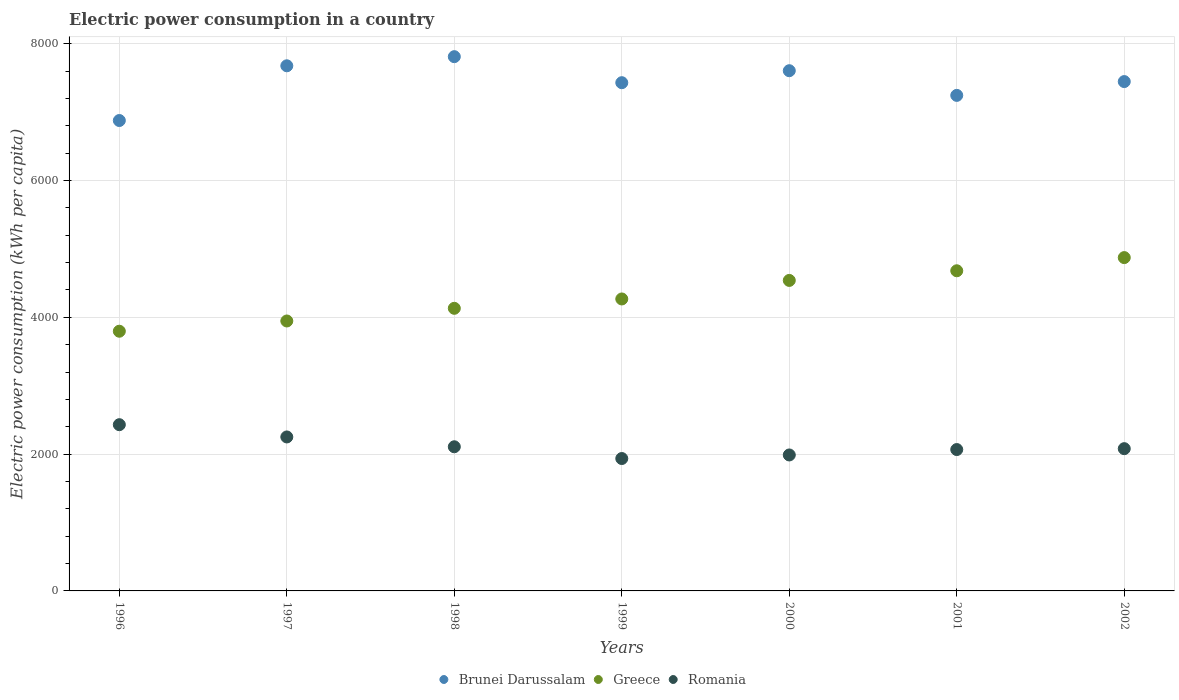How many different coloured dotlines are there?
Give a very brief answer. 3. What is the electric power consumption in in Romania in 1996?
Your answer should be very brief. 2430.3. Across all years, what is the maximum electric power consumption in in Greece?
Make the answer very short. 4873.12. Across all years, what is the minimum electric power consumption in in Greece?
Your answer should be very brief. 3796.75. What is the total electric power consumption in in Brunei Darussalam in the graph?
Make the answer very short. 5.21e+04. What is the difference between the electric power consumption in in Greece in 1996 and that in 1997?
Offer a terse response. -149.71. What is the difference between the electric power consumption in in Brunei Darussalam in 1999 and the electric power consumption in in Romania in 2001?
Ensure brevity in your answer.  5363.45. What is the average electric power consumption in in Brunei Darussalam per year?
Keep it short and to the point. 7441.71. In the year 2002, what is the difference between the electric power consumption in in Greece and electric power consumption in in Brunei Darussalam?
Offer a terse response. -2573.38. In how many years, is the electric power consumption in in Brunei Darussalam greater than 6000 kWh per capita?
Keep it short and to the point. 7. What is the ratio of the electric power consumption in in Brunei Darussalam in 2001 to that in 2002?
Offer a terse response. 0.97. Is the electric power consumption in in Greece in 1998 less than that in 2000?
Your answer should be compact. Yes. Is the difference between the electric power consumption in in Greece in 2001 and 2002 greater than the difference between the electric power consumption in in Brunei Darussalam in 2001 and 2002?
Offer a terse response. Yes. What is the difference between the highest and the second highest electric power consumption in in Brunei Darussalam?
Provide a succinct answer. 133.44. What is the difference between the highest and the lowest electric power consumption in in Romania?
Ensure brevity in your answer.  494.74. In how many years, is the electric power consumption in in Greece greater than the average electric power consumption in in Greece taken over all years?
Provide a short and direct response. 3. Does the electric power consumption in in Greece monotonically increase over the years?
Give a very brief answer. Yes. Is the electric power consumption in in Romania strictly greater than the electric power consumption in in Greece over the years?
Ensure brevity in your answer.  No. How many years are there in the graph?
Your answer should be very brief. 7. What is the difference between two consecutive major ticks on the Y-axis?
Your answer should be compact. 2000. Are the values on the major ticks of Y-axis written in scientific E-notation?
Give a very brief answer. No. Does the graph contain grids?
Your answer should be compact. Yes. How many legend labels are there?
Your answer should be very brief. 3. What is the title of the graph?
Make the answer very short. Electric power consumption in a country. What is the label or title of the X-axis?
Your response must be concise. Years. What is the label or title of the Y-axis?
Give a very brief answer. Electric power consumption (kWh per capita). What is the Electric power consumption (kWh per capita) of Brunei Darussalam in 1996?
Give a very brief answer. 6877.19. What is the Electric power consumption (kWh per capita) of Greece in 1996?
Offer a terse response. 3796.75. What is the Electric power consumption (kWh per capita) in Romania in 1996?
Provide a short and direct response. 2430.3. What is the Electric power consumption (kWh per capita) in Brunei Darussalam in 1997?
Provide a succinct answer. 7677.26. What is the Electric power consumption (kWh per capita) of Greece in 1997?
Ensure brevity in your answer.  3946.46. What is the Electric power consumption (kWh per capita) in Romania in 1997?
Give a very brief answer. 2251. What is the Electric power consumption (kWh per capita) of Brunei Darussalam in 1998?
Your response must be concise. 7810.7. What is the Electric power consumption (kWh per capita) of Greece in 1998?
Offer a terse response. 4131.66. What is the Electric power consumption (kWh per capita) in Romania in 1998?
Provide a short and direct response. 2107.45. What is the Electric power consumption (kWh per capita) in Brunei Darussalam in 1999?
Make the answer very short. 7430.24. What is the Electric power consumption (kWh per capita) in Greece in 1999?
Offer a very short reply. 4268.38. What is the Electric power consumption (kWh per capita) of Romania in 1999?
Make the answer very short. 1935.56. What is the Electric power consumption (kWh per capita) of Brunei Darussalam in 2000?
Your response must be concise. 7605.41. What is the Electric power consumption (kWh per capita) of Greece in 2000?
Provide a succinct answer. 4539.42. What is the Electric power consumption (kWh per capita) of Romania in 2000?
Provide a succinct answer. 1987.66. What is the Electric power consumption (kWh per capita) in Brunei Darussalam in 2001?
Your answer should be compact. 7244.7. What is the Electric power consumption (kWh per capita) in Greece in 2001?
Your answer should be compact. 4680.52. What is the Electric power consumption (kWh per capita) in Romania in 2001?
Your answer should be compact. 2066.78. What is the Electric power consumption (kWh per capita) in Brunei Darussalam in 2002?
Make the answer very short. 7446.5. What is the Electric power consumption (kWh per capita) of Greece in 2002?
Provide a short and direct response. 4873.12. What is the Electric power consumption (kWh per capita) in Romania in 2002?
Give a very brief answer. 2079.8. Across all years, what is the maximum Electric power consumption (kWh per capita) of Brunei Darussalam?
Provide a succinct answer. 7810.7. Across all years, what is the maximum Electric power consumption (kWh per capita) in Greece?
Offer a very short reply. 4873.12. Across all years, what is the maximum Electric power consumption (kWh per capita) of Romania?
Your answer should be compact. 2430.3. Across all years, what is the minimum Electric power consumption (kWh per capita) of Brunei Darussalam?
Keep it short and to the point. 6877.19. Across all years, what is the minimum Electric power consumption (kWh per capita) of Greece?
Provide a short and direct response. 3796.75. Across all years, what is the minimum Electric power consumption (kWh per capita) in Romania?
Offer a terse response. 1935.56. What is the total Electric power consumption (kWh per capita) in Brunei Darussalam in the graph?
Your answer should be compact. 5.21e+04. What is the total Electric power consumption (kWh per capita) in Greece in the graph?
Offer a terse response. 3.02e+04. What is the total Electric power consumption (kWh per capita) in Romania in the graph?
Provide a succinct answer. 1.49e+04. What is the difference between the Electric power consumption (kWh per capita) in Brunei Darussalam in 1996 and that in 1997?
Your response must be concise. -800.07. What is the difference between the Electric power consumption (kWh per capita) of Greece in 1996 and that in 1997?
Your answer should be compact. -149.71. What is the difference between the Electric power consumption (kWh per capita) of Romania in 1996 and that in 1997?
Keep it short and to the point. 179.3. What is the difference between the Electric power consumption (kWh per capita) of Brunei Darussalam in 1996 and that in 1998?
Provide a succinct answer. -933.51. What is the difference between the Electric power consumption (kWh per capita) of Greece in 1996 and that in 1998?
Your answer should be very brief. -334.91. What is the difference between the Electric power consumption (kWh per capita) in Romania in 1996 and that in 1998?
Your answer should be very brief. 322.86. What is the difference between the Electric power consumption (kWh per capita) in Brunei Darussalam in 1996 and that in 1999?
Provide a short and direct response. -553.04. What is the difference between the Electric power consumption (kWh per capita) of Greece in 1996 and that in 1999?
Provide a short and direct response. -471.64. What is the difference between the Electric power consumption (kWh per capita) in Romania in 1996 and that in 1999?
Make the answer very short. 494.74. What is the difference between the Electric power consumption (kWh per capita) of Brunei Darussalam in 1996 and that in 2000?
Your response must be concise. -728.22. What is the difference between the Electric power consumption (kWh per capita) in Greece in 1996 and that in 2000?
Provide a succinct answer. -742.67. What is the difference between the Electric power consumption (kWh per capita) of Romania in 1996 and that in 2000?
Provide a short and direct response. 442.64. What is the difference between the Electric power consumption (kWh per capita) in Brunei Darussalam in 1996 and that in 2001?
Give a very brief answer. -367.51. What is the difference between the Electric power consumption (kWh per capita) of Greece in 1996 and that in 2001?
Make the answer very short. -883.78. What is the difference between the Electric power consumption (kWh per capita) in Romania in 1996 and that in 2001?
Offer a terse response. 363.52. What is the difference between the Electric power consumption (kWh per capita) in Brunei Darussalam in 1996 and that in 2002?
Give a very brief answer. -569.3. What is the difference between the Electric power consumption (kWh per capita) of Greece in 1996 and that in 2002?
Your answer should be very brief. -1076.37. What is the difference between the Electric power consumption (kWh per capita) of Romania in 1996 and that in 2002?
Offer a very short reply. 350.51. What is the difference between the Electric power consumption (kWh per capita) of Brunei Darussalam in 1997 and that in 1998?
Make the answer very short. -133.44. What is the difference between the Electric power consumption (kWh per capita) in Greece in 1997 and that in 1998?
Your answer should be compact. -185.2. What is the difference between the Electric power consumption (kWh per capita) of Romania in 1997 and that in 1998?
Your answer should be compact. 143.55. What is the difference between the Electric power consumption (kWh per capita) of Brunei Darussalam in 1997 and that in 1999?
Give a very brief answer. 247.02. What is the difference between the Electric power consumption (kWh per capita) of Greece in 1997 and that in 1999?
Give a very brief answer. -321.93. What is the difference between the Electric power consumption (kWh per capita) of Romania in 1997 and that in 1999?
Your answer should be very brief. 315.44. What is the difference between the Electric power consumption (kWh per capita) in Brunei Darussalam in 1997 and that in 2000?
Provide a short and direct response. 71.84. What is the difference between the Electric power consumption (kWh per capita) in Greece in 1997 and that in 2000?
Give a very brief answer. -592.96. What is the difference between the Electric power consumption (kWh per capita) in Romania in 1997 and that in 2000?
Give a very brief answer. 263.34. What is the difference between the Electric power consumption (kWh per capita) in Brunei Darussalam in 1997 and that in 2001?
Your answer should be compact. 432.56. What is the difference between the Electric power consumption (kWh per capita) of Greece in 1997 and that in 2001?
Keep it short and to the point. -734.07. What is the difference between the Electric power consumption (kWh per capita) of Romania in 1997 and that in 2001?
Provide a short and direct response. 184.22. What is the difference between the Electric power consumption (kWh per capita) in Brunei Darussalam in 1997 and that in 2002?
Your response must be concise. 230.76. What is the difference between the Electric power consumption (kWh per capita) in Greece in 1997 and that in 2002?
Offer a very short reply. -926.66. What is the difference between the Electric power consumption (kWh per capita) of Romania in 1997 and that in 2002?
Make the answer very short. 171.2. What is the difference between the Electric power consumption (kWh per capita) of Brunei Darussalam in 1998 and that in 1999?
Offer a terse response. 380.46. What is the difference between the Electric power consumption (kWh per capita) of Greece in 1998 and that in 1999?
Make the answer very short. -136.72. What is the difference between the Electric power consumption (kWh per capita) of Romania in 1998 and that in 1999?
Provide a succinct answer. 171.88. What is the difference between the Electric power consumption (kWh per capita) of Brunei Darussalam in 1998 and that in 2000?
Your response must be concise. 205.29. What is the difference between the Electric power consumption (kWh per capita) in Greece in 1998 and that in 2000?
Provide a short and direct response. -407.76. What is the difference between the Electric power consumption (kWh per capita) of Romania in 1998 and that in 2000?
Your answer should be very brief. 119.79. What is the difference between the Electric power consumption (kWh per capita) of Brunei Darussalam in 1998 and that in 2001?
Ensure brevity in your answer.  566. What is the difference between the Electric power consumption (kWh per capita) in Greece in 1998 and that in 2001?
Provide a succinct answer. -548.87. What is the difference between the Electric power consumption (kWh per capita) in Romania in 1998 and that in 2001?
Your answer should be compact. 40.66. What is the difference between the Electric power consumption (kWh per capita) of Brunei Darussalam in 1998 and that in 2002?
Your answer should be very brief. 364.2. What is the difference between the Electric power consumption (kWh per capita) of Greece in 1998 and that in 2002?
Offer a terse response. -741.46. What is the difference between the Electric power consumption (kWh per capita) of Romania in 1998 and that in 2002?
Make the answer very short. 27.65. What is the difference between the Electric power consumption (kWh per capita) in Brunei Darussalam in 1999 and that in 2000?
Give a very brief answer. -175.18. What is the difference between the Electric power consumption (kWh per capita) in Greece in 1999 and that in 2000?
Provide a short and direct response. -271.04. What is the difference between the Electric power consumption (kWh per capita) of Romania in 1999 and that in 2000?
Keep it short and to the point. -52.1. What is the difference between the Electric power consumption (kWh per capita) in Brunei Darussalam in 1999 and that in 2001?
Offer a terse response. 185.54. What is the difference between the Electric power consumption (kWh per capita) in Greece in 1999 and that in 2001?
Provide a succinct answer. -412.14. What is the difference between the Electric power consumption (kWh per capita) of Romania in 1999 and that in 2001?
Provide a succinct answer. -131.22. What is the difference between the Electric power consumption (kWh per capita) in Brunei Darussalam in 1999 and that in 2002?
Provide a succinct answer. -16.26. What is the difference between the Electric power consumption (kWh per capita) of Greece in 1999 and that in 2002?
Offer a terse response. -604.74. What is the difference between the Electric power consumption (kWh per capita) in Romania in 1999 and that in 2002?
Provide a short and direct response. -144.24. What is the difference between the Electric power consumption (kWh per capita) of Brunei Darussalam in 2000 and that in 2001?
Your response must be concise. 360.71. What is the difference between the Electric power consumption (kWh per capita) in Greece in 2000 and that in 2001?
Make the answer very short. -141.11. What is the difference between the Electric power consumption (kWh per capita) of Romania in 2000 and that in 2001?
Make the answer very short. -79.12. What is the difference between the Electric power consumption (kWh per capita) of Brunei Darussalam in 2000 and that in 2002?
Make the answer very short. 158.92. What is the difference between the Electric power consumption (kWh per capita) of Greece in 2000 and that in 2002?
Provide a short and direct response. -333.7. What is the difference between the Electric power consumption (kWh per capita) of Romania in 2000 and that in 2002?
Give a very brief answer. -92.14. What is the difference between the Electric power consumption (kWh per capita) of Brunei Darussalam in 2001 and that in 2002?
Make the answer very short. -201.8. What is the difference between the Electric power consumption (kWh per capita) in Greece in 2001 and that in 2002?
Make the answer very short. -192.6. What is the difference between the Electric power consumption (kWh per capita) of Romania in 2001 and that in 2002?
Your answer should be compact. -13.01. What is the difference between the Electric power consumption (kWh per capita) of Brunei Darussalam in 1996 and the Electric power consumption (kWh per capita) of Greece in 1997?
Offer a very short reply. 2930.74. What is the difference between the Electric power consumption (kWh per capita) of Brunei Darussalam in 1996 and the Electric power consumption (kWh per capita) of Romania in 1997?
Your response must be concise. 4626.19. What is the difference between the Electric power consumption (kWh per capita) of Greece in 1996 and the Electric power consumption (kWh per capita) of Romania in 1997?
Ensure brevity in your answer.  1545.75. What is the difference between the Electric power consumption (kWh per capita) of Brunei Darussalam in 1996 and the Electric power consumption (kWh per capita) of Greece in 1998?
Offer a terse response. 2745.54. What is the difference between the Electric power consumption (kWh per capita) in Brunei Darussalam in 1996 and the Electric power consumption (kWh per capita) in Romania in 1998?
Keep it short and to the point. 4769.75. What is the difference between the Electric power consumption (kWh per capita) of Greece in 1996 and the Electric power consumption (kWh per capita) of Romania in 1998?
Provide a short and direct response. 1689.3. What is the difference between the Electric power consumption (kWh per capita) in Brunei Darussalam in 1996 and the Electric power consumption (kWh per capita) in Greece in 1999?
Offer a terse response. 2608.81. What is the difference between the Electric power consumption (kWh per capita) of Brunei Darussalam in 1996 and the Electric power consumption (kWh per capita) of Romania in 1999?
Provide a succinct answer. 4941.63. What is the difference between the Electric power consumption (kWh per capita) of Greece in 1996 and the Electric power consumption (kWh per capita) of Romania in 1999?
Your answer should be compact. 1861.18. What is the difference between the Electric power consumption (kWh per capita) in Brunei Darussalam in 1996 and the Electric power consumption (kWh per capita) in Greece in 2000?
Offer a very short reply. 2337.78. What is the difference between the Electric power consumption (kWh per capita) of Brunei Darussalam in 1996 and the Electric power consumption (kWh per capita) of Romania in 2000?
Your answer should be very brief. 4889.53. What is the difference between the Electric power consumption (kWh per capita) in Greece in 1996 and the Electric power consumption (kWh per capita) in Romania in 2000?
Offer a very short reply. 1809.08. What is the difference between the Electric power consumption (kWh per capita) in Brunei Darussalam in 1996 and the Electric power consumption (kWh per capita) in Greece in 2001?
Offer a terse response. 2196.67. What is the difference between the Electric power consumption (kWh per capita) of Brunei Darussalam in 1996 and the Electric power consumption (kWh per capita) of Romania in 2001?
Offer a terse response. 4810.41. What is the difference between the Electric power consumption (kWh per capita) in Greece in 1996 and the Electric power consumption (kWh per capita) in Romania in 2001?
Give a very brief answer. 1729.96. What is the difference between the Electric power consumption (kWh per capita) in Brunei Darussalam in 1996 and the Electric power consumption (kWh per capita) in Greece in 2002?
Keep it short and to the point. 2004.07. What is the difference between the Electric power consumption (kWh per capita) in Brunei Darussalam in 1996 and the Electric power consumption (kWh per capita) in Romania in 2002?
Provide a succinct answer. 4797.4. What is the difference between the Electric power consumption (kWh per capita) in Greece in 1996 and the Electric power consumption (kWh per capita) in Romania in 2002?
Give a very brief answer. 1716.95. What is the difference between the Electric power consumption (kWh per capita) of Brunei Darussalam in 1997 and the Electric power consumption (kWh per capita) of Greece in 1998?
Offer a terse response. 3545.6. What is the difference between the Electric power consumption (kWh per capita) in Brunei Darussalam in 1997 and the Electric power consumption (kWh per capita) in Romania in 1998?
Your answer should be very brief. 5569.81. What is the difference between the Electric power consumption (kWh per capita) in Greece in 1997 and the Electric power consumption (kWh per capita) in Romania in 1998?
Offer a very short reply. 1839.01. What is the difference between the Electric power consumption (kWh per capita) of Brunei Darussalam in 1997 and the Electric power consumption (kWh per capita) of Greece in 1999?
Your answer should be very brief. 3408.88. What is the difference between the Electric power consumption (kWh per capita) in Brunei Darussalam in 1997 and the Electric power consumption (kWh per capita) in Romania in 1999?
Provide a succinct answer. 5741.7. What is the difference between the Electric power consumption (kWh per capita) of Greece in 1997 and the Electric power consumption (kWh per capita) of Romania in 1999?
Give a very brief answer. 2010.9. What is the difference between the Electric power consumption (kWh per capita) in Brunei Darussalam in 1997 and the Electric power consumption (kWh per capita) in Greece in 2000?
Offer a terse response. 3137.84. What is the difference between the Electric power consumption (kWh per capita) of Brunei Darussalam in 1997 and the Electric power consumption (kWh per capita) of Romania in 2000?
Offer a terse response. 5689.6. What is the difference between the Electric power consumption (kWh per capita) in Greece in 1997 and the Electric power consumption (kWh per capita) in Romania in 2000?
Your answer should be very brief. 1958.8. What is the difference between the Electric power consumption (kWh per capita) in Brunei Darussalam in 1997 and the Electric power consumption (kWh per capita) in Greece in 2001?
Keep it short and to the point. 2996.73. What is the difference between the Electric power consumption (kWh per capita) in Brunei Darussalam in 1997 and the Electric power consumption (kWh per capita) in Romania in 2001?
Your response must be concise. 5610.47. What is the difference between the Electric power consumption (kWh per capita) of Greece in 1997 and the Electric power consumption (kWh per capita) of Romania in 2001?
Your answer should be very brief. 1879.67. What is the difference between the Electric power consumption (kWh per capita) of Brunei Darussalam in 1997 and the Electric power consumption (kWh per capita) of Greece in 2002?
Your answer should be compact. 2804.14. What is the difference between the Electric power consumption (kWh per capita) of Brunei Darussalam in 1997 and the Electric power consumption (kWh per capita) of Romania in 2002?
Your answer should be compact. 5597.46. What is the difference between the Electric power consumption (kWh per capita) in Greece in 1997 and the Electric power consumption (kWh per capita) in Romania in 2002?
Keep it short and to the point. 1866.66. What is the difference between the Electric power consumption (kWh per capita) of Brunei Darussalam in 1998 and the Electric power consumption (kWh per capita) of Greece in 1999?
Offer a terse response. 3542.32. What is the difference between the Electric power consumption (kWh per capita) of Brunei Darussalam in 1998 and the Electric power consumption (kWh per capita) of Romania in 1999?
Give a very brief answer. 5875.14. What is the difference between the Electric power consumption (kWh per capita) of Greece in 1998 and the Electric power consumption (kWh per capita) of Romania in 1999?
Your answer should be compact. 2196.1. What is the difference between the Electric power consumption (kWh per capita) of Brunei Darussalam in 1998 and the Electric power consumption (kWh per capita) of Greece in 2000?
Offer a terse response. 3271.28. What is the difference between the Electric power consumption (kWh per capita) of Brunei Darussalam in 1998 and the Electric power consumption (kWh per capita) of Romania in 2000?
Keep it short and to the point. 5823.04. What is the difference between the Electric power consumption (kWh per capita) of Greece in 1998 and the Electric power consumption (kWh per capita) of Romania in 2000?
Your answer should be very brief. 2144. What is the difference between the Electric power consumption (kWh per capita) of Brunei Darussalam in 1998 and the Electric power consumption (kWh per capita) of Greece in 2001?
Offer a very short reply. 3130.18. What is the difference between the Electric power consumption (kWh per capita) of Brunei Darussalam in 1998 and the Electric power consumption (kWh per capita) of Romania in 2001?
Offer a terse response. 5743.92. What is the difference between the Electric power consumption (kWh per capita) in Greece in 1998 and the Electric power consumption (kWh per capita) in Romania in 2001?
Your response must be concise. 2064.87. What is the difference between the Electric power consumption (kWh per capita) in Brunei Darussalam in 1998 and the Electric power consumption (kWh per capita) in Greece in 2002?
Offer a terse response. 2937.58. What is the difference between the Electric power consumption (kWh per capita) in Brunei Darussalam in 1998 and the Electric power consumption (kWh per capita) in Romania in 2002?
Ensure brevity in your answer.  5730.9. What is the difference between the Electric power consumption (kWh per capita) in Greece in 1998 and the Electric power consumption (kWh per capita) in Romania in 2002?
Your response must be concise. 2051.86. What is the difference between the Electric power consumption (kWh per capita) in Brunei Darussalam in 1999 and the Electric power consumption (kWh per capita) in Greece in 2000?
Your response must be concise. 2890.82. What is the difference between the Electric power consumption (kWh per capita) in Brunei Darussalam in 1999 and the Electric power consumption (kWh per capita) in Romania in 2000?
Your answer should be very brief. 5442.58. What is the difference between the Electric power consumption (kWh per capita) in Greece in 1999 and the Electric power consumption (kWh per capita) in Romania in 2000?
Your response must be concise. 2280.72. What is the difference between the Electric power consumption (kWh per capita) in Brunei Darussalam in 1999 and the Electric power consumption (kWh per capita) in Greece in 2001?
Give a very brief answer. 2749.71. What is the difference between the Electric power consumption (kWh per capita) of Brunei Darussalam in 1999 and the Electric power consumption (kWh per capita) of Romania in 2001?
Keep it short and to the point. 5363.45. What is the difference between the Electric power consumption (kWh per capita) in Greece in 1999 and the Electric power consumption (kWh per capita) in Romania in 2001?
Your answer should be very brief. 2201.6. What is the difference between the Electric power consumption (kWh per capita) of Brunei Darussalam in 1999 and the Electric power consumption (kWh per capita) of Greece in 2002?
Provide a succinct answer. 2557.12. What is the difference between the Electric power consumption (kWh per capita) in Brunei Darussalam in 1999 and the Electric power consumption (kWh per capita) in Romania in 2002?
Your answer should be very brief. 5350.44. What is the difference between the Electric power consumption (kWh per capita) of Greece in 1999 and the Electric power consumption (kWh per capita) of Romania in 2002?
Keep it short and to the point. 2188.59. What is the difference between the Electric power consumption (kWh per capita) in Brunei Darussalam in 2000 and the Electric power consumption (kWh per capita) in Greece in 2001?
Your answer should be compact. 2924.89. What is the difference between the Electric power consumption (kWh per capita) of Brunei Darussalam in 2000 and the Electric power consumption (kWh per capita) of Romania in 2001?
Make the answer very short. 5538.63. What is the difference between the Electric power consumption (kWh per capita) in Greece in 2000 and the Electric power consumption (kWh per capita) in Romania in 2001?
Keep it short and to the point. 2472.63. What is the difference between the Electric power consumption (kWh per capita) of Brunei Darussalam in 2000 and the Electric power consumption (kWh per capita) of Greece in 2002?
Provide a short and direct response. 2732.29. What is the difference between the Electric power consumption (kWh per capita) of Brunei Darussalam in 2000 and the Electric power consumption (kWh per capita) of Romania in 2002?
Provide a short and direct response. 5525.62. What is the difference between the Electric power consumption (kWh per capita) of Greece in 2000 and the Electric power consumption (kWh per capita) of Romania in 2002?
Keep it short and to the point. 2459.62. What is the difference between the Electric power consumption (kWh per capita) of Brunei Darussalam in 2001 and the Electric power consumption (kWh per capita) of Greece in 2002?
Ensure brevity in your answer.  2371.58. What is the difference between the Electric power consumption (kWh per capita) in Brunei Darussalam in 2001 and the Electric power consumption (kWh per capita) in Romania in 2002?
Make the answer very short. 5164.9. What is the difference between the Electric power consumption (kWh per capita) of Greece in 2001 and the Electric power consumption (kWh per capita) of Romania in 2002?
Make the answer very short. 2600.73. What is the average Electric power consumption (kWh per capita) of Brunei Darussalam per year?
Give a very brief answer. 7441.71. What is the average Electric power consumption (kWh per capita) of Greece per year?
Your answer should be compact. 4319.47. What is the average Electric power consumption (kWh per capita) in Romania per year?
Ensure brevity in your answer.  2122.65. In the year 1996, what is the difference between the Electric power consumption (kWh per capita) in Brunei Darussalam and Electric power consumption (kWh per capita) in Greece?
Give a very brief answer. 3080.45. In the year 1996, what is the difference between the Electric power consumption (kWh per capita) of Brunei Darussalam and Electric power consumption (kWh per capita) of Romania?
Ensure brevity in your answer.  4446.89. In the year 1996, what is the difference between the Electric power consumption (kWh per capita) of Greece and Electric power consumption (kWh per capita) of Romania?
Offer a terse response. 1366.44. In the year 1997, what is the difference between the Electric power consumption (kWh per capita) in Brunei Darussalam and Electric power consumption (kWh per capita) in Greece?
Offer a terse response. 3730.8. In the year 1997, what is the difference between the Electric power consumption (kWh per capita) in Brunei Darussalam and Electric power consumption (kWh per capita) in Romania?
Your answer should be compact. 5426.26. In the year 1997, what is the difference between the Electric power consumption (kWh per capita) in Greece and Electric power consumption (kWh per capita) in Romania?
Keep it short and to the point. 1695.46. In the year 1998, what is the difference between the Electric power consumption (kWh per capita) in Brunei Darussalam and Electric power consumption (kWh per capita) in Greece?
Provide a succinct answer. 3679.04. In the year 1998, what is the difference between the Electric power consumption (kWh per capita) of Brunei Darussalam and Electric power consumption (kWh per capita) of Romania?
Your answer should be compact. 5703.25. In the year 1998, what is the difference between the Electric power consumption (kWh per capita) of Greece and Electric power consumption (kWh per capita) of Romania?
Your answer should be compact. 2024.21. In the year 1999, what is the difference between the Electric power consumption (kWh per capita) of Brunei Darussalam and Electric power consumption (kWh per capita) of Greece?
Your answer should be compact. 3161.86. In the year 1999, what is the difference between the Electric power consumption (kWh per capita) in Brunei Darussalam and Electric power consumption (kWh per capita) in Romania?
Offer a terse response. 5494.68. In the year 1999, what is the difference between the Electric power consumption (kWh per capita) of Greece and Electric power consumption (kWh per capita) of Romania?
Your answer should be very brief. 2332.82. In the year 2000, what is the difference between the Electric power consumption (kWh per capita) of Brunei Darussalam and Electric power consumption (kWh per capita) of Greece?
Your answer should be compact. 3066. In the year 2000, what is the difference between the Electric power consumption (kWh per capita) in Brunei Darussalam and Electric power consumption (kWh per capita) in Romania?
Offer a very short reply. 5617.75. In the year 2000, what is the difference between the Electric power consumption (kWh per capita) in Greece and Electric power consumption (kWh per capita) in Romania?
Make the answer very short. 2551.76. In the year 2001, what is the difference between the Electric power consumption (kWh per capita) in Brunei Darussalam and Electric power consumption (kWh per capita) in Greece?
Ensure brevity in your answer.  2564.18. In the year 2001, what is the difference between the Electric power consumption (kWh per capita) in Brunei Darussalam and Electric power consumption (kWh per capita) in Romania?
Your response must be concise. 5177.92. In the year 2001, what is the difference between the Electric power consumption (kWh per capita) of Greece and Electric power consumption (kWh per capita) of Romania?
Ensure brevity in your answer.  2613.74. In the year 2002, what is the difference between the Electric power consumption (kWh per capita) in Brunei Darussalam and Electric power consumption (kWh per capita) in Greece?
Your answer should be compact. 2573.38. In the year 2002, what is the difference between the Electric power consumption (kWh per capita) of Brunei Darussalam and Electric power consumption (kWh per capita) of Romania?
Ensure brevity in your answer.  5366.7. In the year 2002, what is the difference between the Electric power consumption (kWh per capita) of Greece and Electric power consumption (kWh per capita) of Romania?
Your response must be concise. 2793.32. What is the ratio of the Electric power consumption (kWh per capita) of Brunei Darussalam in 1996 to that in 1997?
Provide a short and direct response. 0.9. What is the ratio of the Electric power consumption (kWh per capita) in Greece in 1996 to that in 1997?
Give a very brief answer. 0.96. What is the ratio of the Electric power consumption (kWh per capita) of Romania in 1996 to that in 1997?
Your response must be concise. 1.08. What is the ratio of the Electric power consumption (kWh per capita) in Brunei Darussalam in 1996 to that in 1998?
Ensure brevity in your answer.  0.88. What is the ratio of the Electric power consumption (kWh per capita) of Greece in 1996 to that in 1998?
Provide a short and direct response. 0.92. What is the ratio of the Electric power consumption (kWh per capita) in Romania in 1996 to that in 1998?
Your answer should be compact. 1.15. What is the ratio of the Electric power consumption (kWh per capita) in Brunei Darussalam in 1996 to that in 1999?
Your response must be concise. 0.93. What is the ratio of the Electric power consumption (kWh per capita) in Greece in 1996 to that in 1999?
Ensure brevity in your answer.  0.89. What is the ratio of the Electric power consumption (kWh per capita) in Romania in 1996 to that in 1999?
Provide a succinct answer. 1.26. What is the ratio of the Electric power consumption (kWh per capita) in Brunei Darussalam in 1996 to that in 2000?
Give a very brief answer. 0.9. What is the ratio of the Electric power consumption (kWh per capita) in Greece in 1996 to that in 2000?
Your answer should be compact. 0.84. What is the ratio of the Electric power consumption (kWh per capita) in Romania in 1996 to that in 2000?
Ensure brevity in your answer.  1.22. What is the ratio of the Electric power consumption (kWh per capita) of Brunei Darussalam in 1996 to that in 2001?
Ensure brevity in your answer.  0.95. What is the ratio of the Electric power consumption (kWh per capita) in Greece in 1996 to that in 2001?
Make the answer very short. 0.81. What is the ratio of the Electric power consumption (kWh per capita) in Romania in 1996 to that in 2001?
Give a very brief answer. 1.18. What is the ratio of the Electric power consumption (kWh per capita) of Brunei Darussalam in 1996 to that in 2002?
Keep it short and to the point. 0.92. What is the ratio of the Electric power consumption (kWh per capita) in Greece in 1996 to that in 2002?
Give a very brief answer. 0.78. What is the ratio of the Electric power consumption (kWh per capita) in Romania in 1996 to that in 2002?
Give a very brief answer. 1.17. What is the ratio of the Electric power consumption (kWh per capita) of Brunei Darussalam in 1997 to that in 1998?
Your response must be concise. 0.98. What is the ratio of the Electric power consumption (kWh per capita) of Greece in 1997 to that in 1998?
Your response must be concise. 0.96. What is the ratio of the Electric power consumption (kWh per capita) in Romania in 1997 to that in 1998?
Provide a succinct answer. 1.07. What is the ratio of the Electric power consumption (kWh per capita) in Brunei Darussalam in 1997 to that in 1999?
Offer a terse response. 1.03. What is the ratio of the Electric power consumption (kWh per capita) of Greece in 1997 to that in 1999?
Provide a short and direct response. 0.92. What is the ratio of the Electric power consumption (kWh per capita) of Romania in 1997 to that in 1999?
Give a very brief answer. 1.16. What is the ratio of the Electric power consumption (kWh per capita) of Brunei Darussalam in 1997 to that in 2000?
Your answer should be very brief. 1.01. What is the ratio of the Electric power consumption (kWh per capita) in Greece in 1997 to that in 2000?
Your answer should be compact. 0.87. What is the ratio of the Electric power consumption (kWh per capita) of Romania in 1997 to that in 2000?
Provide a succinct answer. 1.13. What is the ratio of the Electric power consumption (kWh per capita) of Brunei Darussalam in 1997 to that in 2001?
Provide a succinct answer. 1.06. What is the ratio of the Electric power consumption (kWh per capita) in Greece in 1997 to that in 2001?
Offer a terse response. 0.84. What is the ratio of the Electric power consumption (kWh per capita) in Romania in 1997 to that in 2001?
Provide a succinct answer. 1.09. What is the ratio of the Electric power consumption (kWh per capita) in Brunei Darussalam in 1997 to that in 2002?
Make the answer very short. 1.03. What is the ratio of the Electric power consumption (kWh per capita) of Greece in 1997 to that in 2002?
Offer a very short reply. 0.81. What is the ratio of the Electric power consumption (kWh per capita) in Romania in 1997 to that in 2002?
Provide a short and direct response. 1.08. What is the ratio of the Electric power consumption (kWh per capita) of Brunei Darussalam in 1998 to that in 1999?
Keep it short and to the point. 1.05. What is the ratio of the Electric power consumption (kWh per capita) of Greece in 1998 to that in 1999?
Ensure brevity in your answer.  0.97. What is the ratio of the Electric power consumption (kWh per capita) in Romania in 1998 to that in 1999?
Offer a very short reply. 1.09. What is the ratio of the Electric power consumption (kWh per capita) of Greece in 1998 to that in 2000?
Your response must be concise. 0.91. What is the ratio of the Electric power consumption (kWh per capita) in Romania in 1998 to that in 2000?
Give a very brief answer. 1.06. What is the ratio of the Electric power consumption (kWh per capita) in Brunei Darussalam in 1998 to that in 2001?
Ensure brevity in your answer.  1.08. What is the ratio of the Electric power consumption (kWh per capita) in Greece in 1998 to that in 2001?
Your answer should be compact. 0.88. What is the ratio of the Electric power consumption (kWh per capita) in Romania in 1998 to that in 2001?
Provide a short and direct response. 1.02. What is the ratio of the Electric power consumption (kWh per capita) in Brunei Darussalam in 1998 to that in 2002?
Provide a short and direct response. 1.05. What is the ratio of the Electric power consumption (kWh per capita) of Greece in 1998 to that in 2002?
Ensure brevity in your answer.  0.85. What is the ratio of the Electric power consumption (kWh per capita) in Romania in 1998 to that in 2002?
Provide a short and direct response. 1.01. What is the ratio of the Electric power consumption (kWh per capita) of Brunei Darussalam in 1999 to that in 2000?
Provide a succinct answer. 0.98. What is the ratio of the Electric power consumption (kWh per capita) in Greece in 1999 to that in 2000?
Provide a short and direct response. 0.94. What is the ratio of the Electric power consumption (kWh per capita) in Romania in 1999 to that in 2000?
Provide a succinct answer. 0.97. What is the ratio of the Electric power consumption (kWh per capita) of Brunei Darussalam in 1999 to that in 2001?
Provide a short and direct response. 1.03. What is the ratio of the Electric power consumption (kWh per capita) of Greece in 1999 to that in 2001?
Give a very brief answer. 0.91. What is the ratio of the Electric power consumption (kWh per capita) of Romania in 1999 to that in 2001?
Offer a very short reply. 0.94. What is the ratio of the Electric power consumption (kWh per capita) in Brunei Darussalam in 1999 to that in 2002?
Keep it short and to the point. 1. What is the ratio of the Electric power consumption (kWh per capita) of Greece in 1999 to that in 2002?
Your answer should be compact. 0.88. What is the ratio of the Electric power consumption (kWh per capita) in Romania in 1999 to that in 2002?
Keep it short and to the point. 0.93. What is the ratio of the Electric power consumption (kWh per capita) of Brunei Darussalam in 2000 to that in 2001?
Provide a short and direct response. 1.05. What is the ratio of the Electric power consumption (kWh per capita) in Greece in 2000 to that in 2001?
Provide a succinct answer. 0.97. What is the ratio of the Electric power consumption (kWh per capita) in Romania in 2000 to that in 2001?
Give a very brief answer. 0.96. What is the ratio of the Electric power consumption (kWh per capita) of Brunei Darussalam in 2000 to that in 2002?
Your answer should be compact. 1.02. What is the ratio of the Electric power consumption (kWh per capita) in Greece in 2000 to that in 2002?
Offer a very short reply. 0.93. What is the ratio of the Electric power consumption (kWh per capita) in Romania in 2000 to that in 2002?
Provide a succinct answer. 0.96. What is the ratio of the Electric power consumption (kWh per capita) of Brunei Darussalam in 2001 to that in 2002?
Provide a short and direct response. 0.97. What is the ratio of the Electric power consumption (kWh per capita) of Greece in 2001 to that in 2002?
Keep it short and to the point. 0.96. What is the difference between the highest and the second highest Electric power consumption (kWh per capita) of Brunei Darussalam?
Provide a short and direct response. 133.44. What is the difference between the highest and the second highest Electric power consumption (kWh per capita) in Greece?
Offer a very short reply. 192.6. What is the difference between the highest and the second highest Electric power consumption (kWh per capita) in Romania?
Offer a very short reply. 179.3. What is the difference between the highest and the lowest Electric power consumption (kWh per capita) in Brunei Darussalam?
Offer a very short reply. 933.51. What is the difference between the highest and the lowest Electric power consumption (kWh per capita) in Greece?
Ensure brevity in your answer.  1076.37. What is the difference between the highest and the lowest Electric power consumption (kWh per capita) in Romania?
Your answer should be very brief. 494.74. 